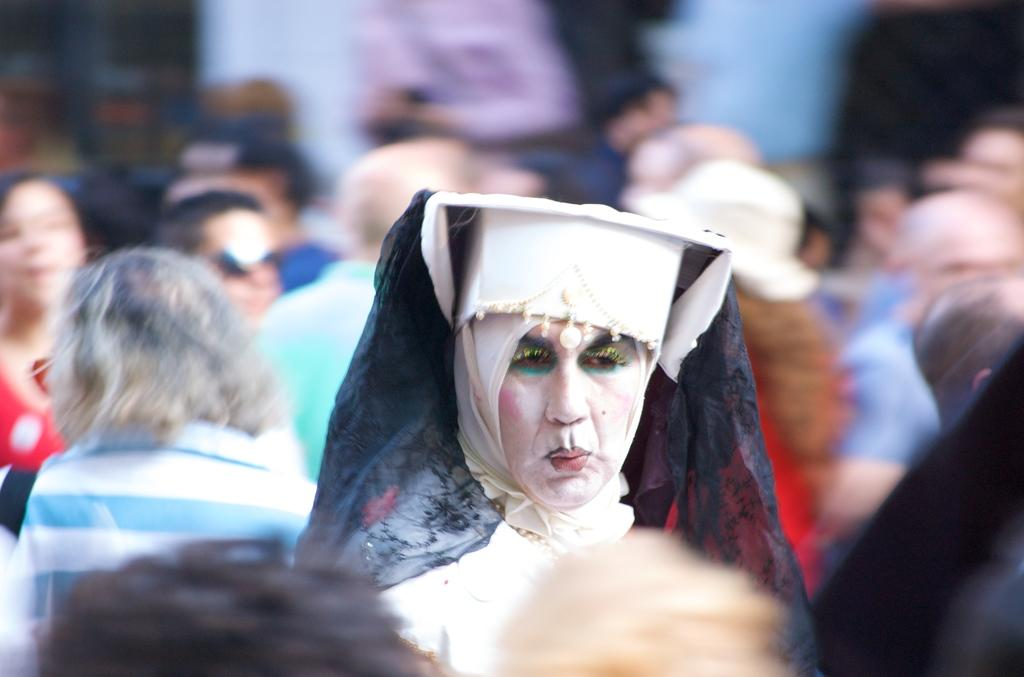What is the main subject of the image? The main subject of the image is a group of people. Can you describe the person in the middle of the image? The person in the middle of the image is wearing a costume. How does the background of the image appear? The background of the image is blurry. What type of produce is being harvested by the beast in the image? There is no beast or produce present in the image; it features a group of people with a person in the middle wearing a costume. 